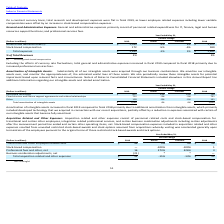Looking at Oracle Corporation's financial data, please calculate: How much was the average total acquisition related and other expenses in 2018 and 2019? To answer this question, I need to perform calculations using the financial data. The calculation is: (44+52) / 2 , which equals 48 (in millions). This is based on the information: "Total acquisition related and other expenses $ 44 -15% -13% $ 52 ition related and other expenses $ 44 -15% -13% $ 52..." The key data points involved are: 44, 52. Also, can you calculate: What was the difference between the transitional and other employee related costs in 2019 and 2018? Based on the calculation: 49-48 , the result is 1 (in millions). This is based on the information: "Transitional and other employee related costs $ 49 3% 4% $ 48 nal and other employee related costs $ 49 3% 4% $ 48..." The key data points involved are: 48, 49. Also, can you calculate: What was the total amount spent on transitional and other employee related costs and professional fees and other, net in 2019? Based on the calculation: 49 + 16 , the result is 65 (in millions). This is based on the information: "Transitional and other employee related costs $ 49 3% 4% $ 48 Professional fees and other, net 16 373% 426% 3..." The key data points involved are: 16, 49. Also, What is included in stock-based compensation expenses? Stock-based compensation expenses included in acquisition related and other expenses resulted from unvested restricted stock-based awards and stock options assumed from acquisitions whereby vesting was accelerated generally upon termination of the employees pursuant to the original terms of those restricted stock-based awards and stock options. The document states: "has ended and certain other operating items, net. Stock-based compensation expenses included in acquisition related and other expenses resulted from u..." Also, How much was the actual and constant percentage change in professional fees and other, net? The document shows two values: 373% and 426% (percentage). From the document: "Professional fees and other, net 16 373% 426% 3 Professional fees and other, net 16 373% 426% 3..." Also, Why did acquisition related and other expenses decrease in fiscal 2019 compared to fiscal 2018? Based on the financial document, the answer is acquisition related and other expenses decreased in fiscal 2019 compared to fiscal 2018 primarily due to certain favorable business combination related adjustments that were recorded in fiscal 201 9 .. 